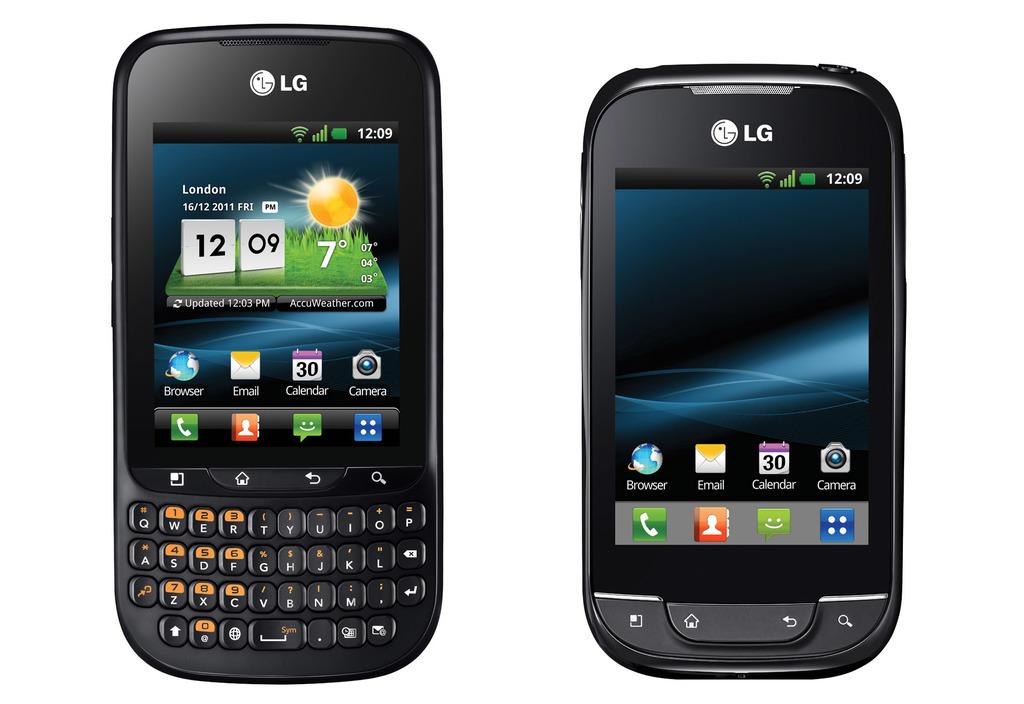What brand is this phone?
Provide a succinct answer. Lg. What is the time shown on the phone on the left?
Offer a very short reply. 12:09. 